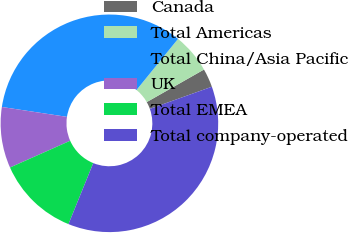<chart> <loc_0><loc_0><loc_500><loc_500><pie_chart><fcel>Canada<fcel>Total Americas<fcel>Total China/Asia Pacific<fcel>UK<fcel>Total EMEA<fcel>Total company-operated<nl><fcel>2.77%<fcel>5.91%<fcel>33.46%<fcel>9.06%<fcel>12.2%<fcel>36.6%<nl></chart> 